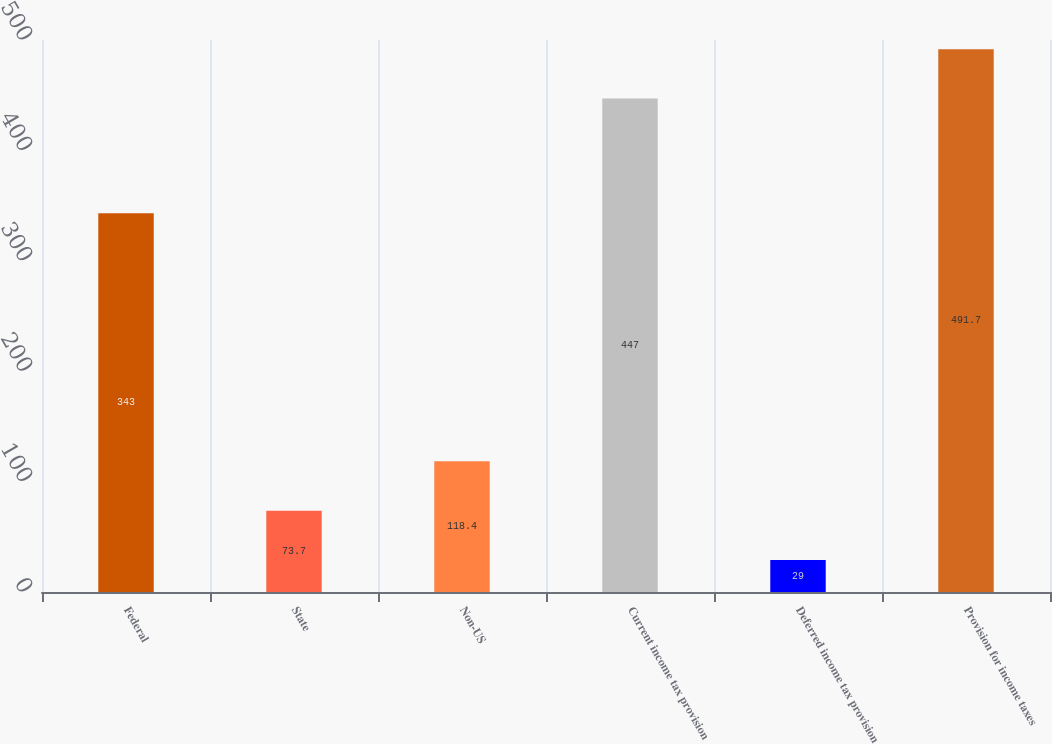<chart> <loc_0><loc_0><loc_500><loc_500><bar_chart><fcel>Federal<fcel>State<fcel>Non-US<fcel>Current income tax provision<fcel>Deferred income tax provision<fcel>Provision for income taxes<nl><fcel>343<fcel>73.7<fcel>118.4<fcel>447<fcel>29<fcel>491.7<nl></chart> 